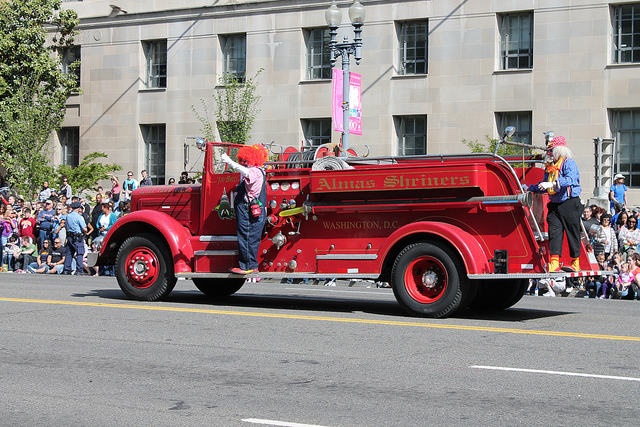Please identify all text content in this image. Almas Shriners 